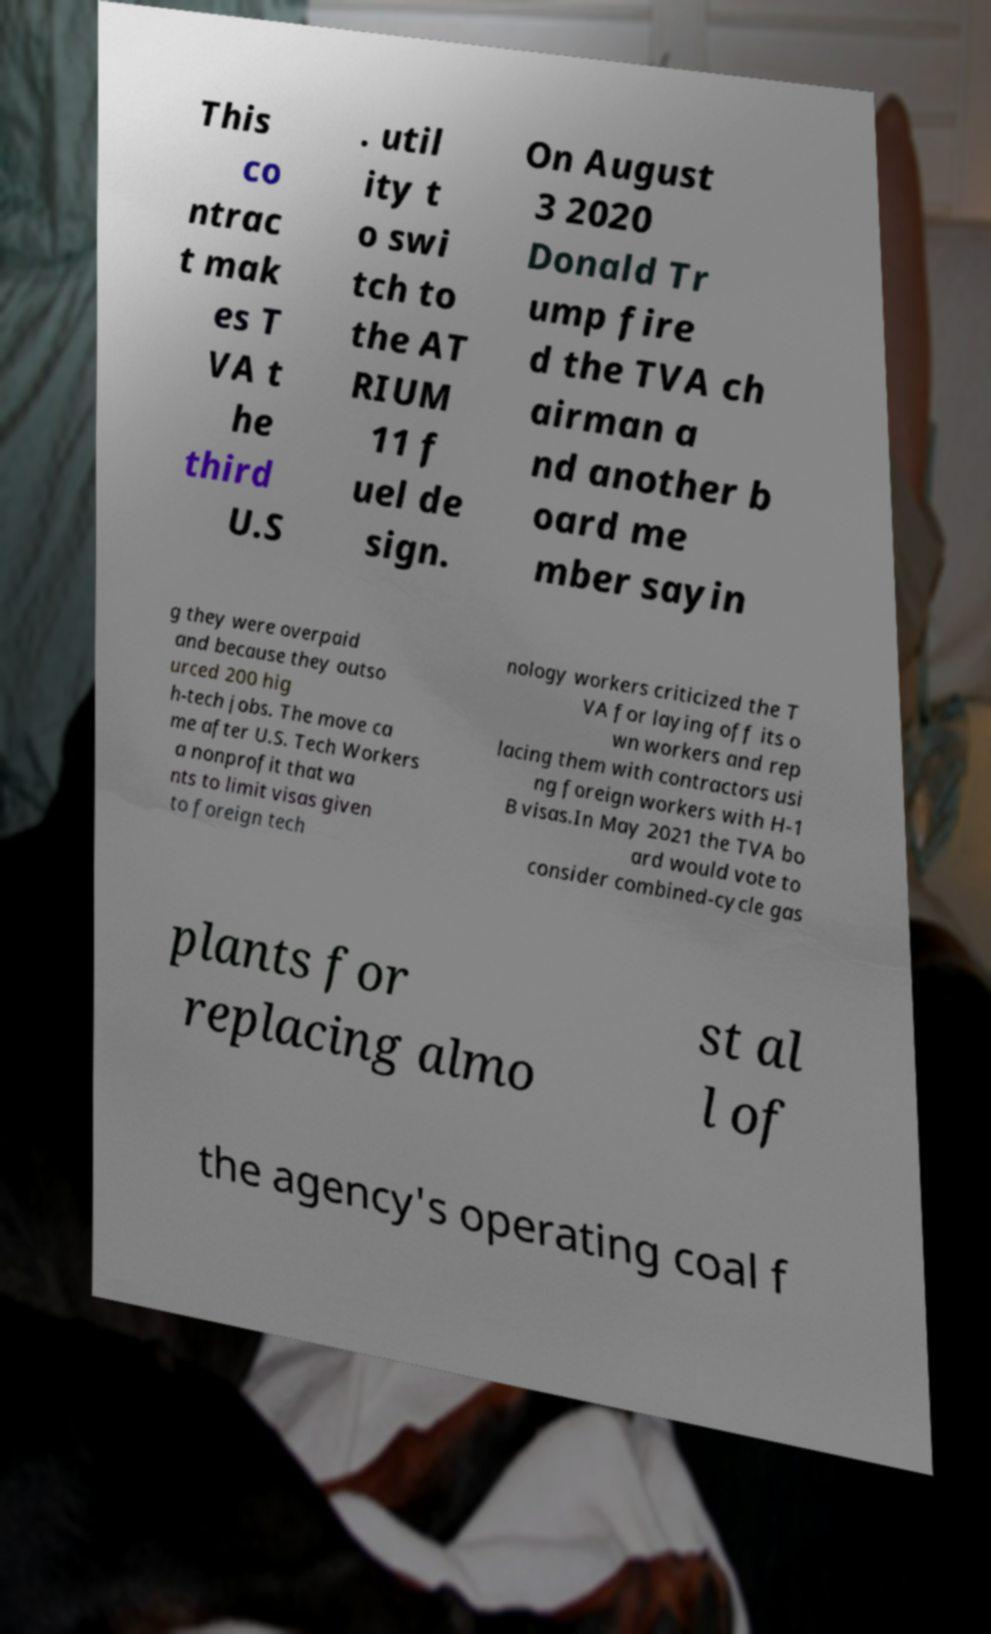Please identify and transcribe the text found in this image. This co ntrac t mak es T VA t he third U.S . util ity t o swi tch to the AT RIUM 11 f uel de sign. On August 3 2020 Donald Tr ump fire d the TVA ch airman a nd another b oard me mber sayin g they were overpaid and because they outso urced 200 hig h-tech jobs. The move ca me after U.S. Tech Workers a nonprofit that wa nts to limit visas given to foreign tech nology workers criticized the T VA for laying off its o wn workers and rep lacing them with contractors usi ng foreign workers with H-1 B visas.In May 2021 the TVA bo ard would vote to consider combined-cycle gas plants for replacing almo st al l of the agency's operating coal f 